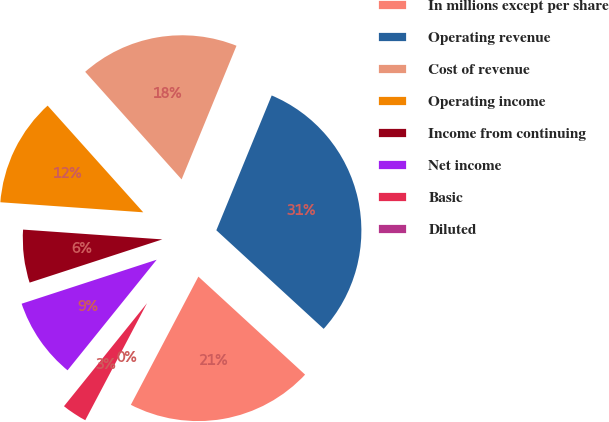<chart> <loc_0><loc_0><loc_500><loc_500><pie_chart><fcel>In millions except per share<fcel>Operating revenue<fcel>Cost of revenue<fcel>Operating income<fcel>Income from continuing<fcel>Net income<fcel>Basic<fcel>Diluted<nl><fcel>20.89%<fcel>30.62%<fcel>17.83%<fcel>12.25%<fcel>6.13%<fcel>9.19%<fcel>3.07%<fcel>0.01%<nl></chart> 